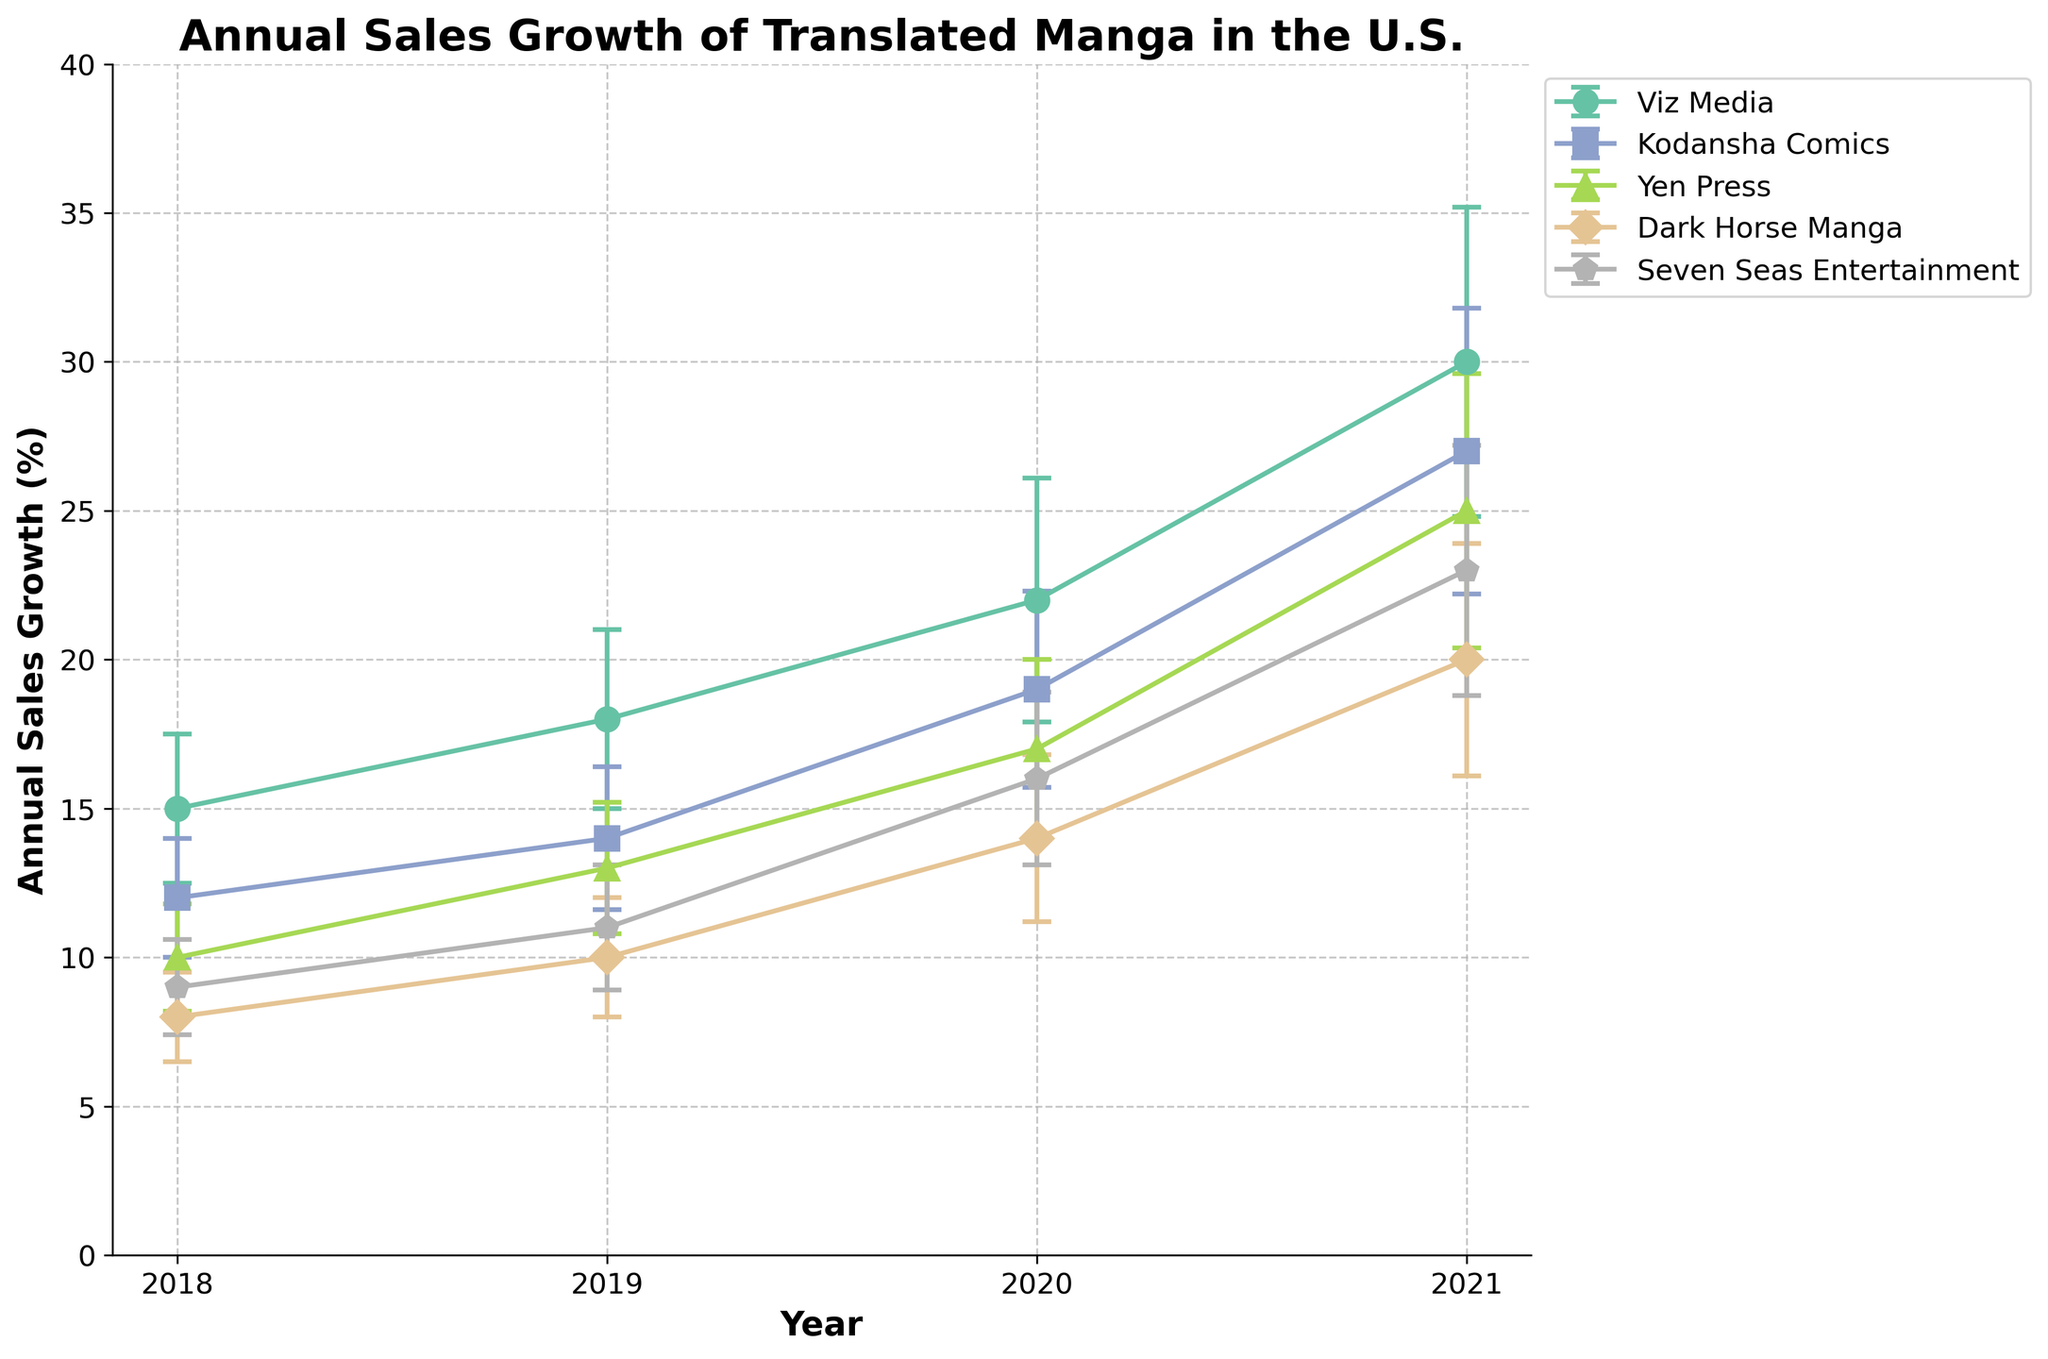What is the title of the figure? The title is often displayed at the top of the figure. From the description, the title is "Annual Sales Growth of Translated Manga in the U.S."
Answer: Annual Sales Growth of Translated Manga in the U.S Which publisher had the highest annual sales growth in 2021? To find the publisher with the highest annual sales growth in 2021, locate the respective markers for 2021 and compare the values. Viz Media had the highest growth with 30%.
Answer: Viz Media How does Viz Media’s sales growth in 2020 compare to its growth in 2019? Locate Viz Media's markers for 2019 and 2020. In 2019, the growth was 18%, and in 2020, it was 22%. Hence, the growth increased by 4 percent points.
Answer: Increased by 4% What can you say about the error bars for Viz Media’s sales growth in 2021 compared to 2019? To compare the error bars for 2021 and 2019 for Viz Media, observe the length of the error bars. The standard deviation is larger in 2021 (5.2) than in 2019 (3.0), indicating more variability in 2021.
Answer: More variability in 2021 Which publisher had the smallest standard deviation in 2018? To find the smallest standard deviation in 2018, compare the lengths of the error bars for all publishers in that year. Dark Horse Manga had the smallest standard deviation at 1.5.
Answer: Dark Horse Manga Did any publisher have a consistent increase in sales growth every year from 2018 to 2021? To determine consistency in growth, check if the growth values continually increase each year for each publisher. Viz Media, Kodansha Comics, Yen Press, Dark Horse Manga, and Seven Seas Entertainment all showed consistent increases.
Answer: Yes, all publishers How much did Yen Press’s sales growth increase in total from 2018 to 2021? Find Yen Press's growth values for 2018 and 2021 (10% and 25%). The total increase is 25% - 10% = 15%.
Answer: 15% Which year shows the greatest variability among the publishers? To detect the greatest variability, look at the error bars’ lengths across all publishers for each year. In 2021, the error bars are the longest on average, indicating the most variability.
Answer: 2021 What is the difference in annual sales growth between Kodansha Comics and Seven Seas Entertainment in 2020? Locate the growth values for 2020: Kodansha Comics (19%) and Seven Seas Entertainment (16%). The difference is 19% - 16% = 3%.
Answer: 3% Which publisher had the largest increase in standard deviation from 2018 to 2021? To find the publisher with the largest increase in standard deviation, calculate the difference in standard deviations for each publisher between 2018 and 2021. For Viz Media, it changed from 2.5 to 5.2, an increase of 2.7, which is the largest.
Answer: Viz Media 